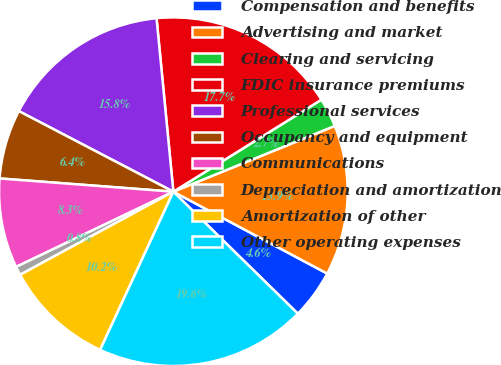<chart> <loc_0><loc_0><loc_500><loc_500><pie_chart><fcel>Compensation and benefits<fcel>Advertising and market<fcel>Clearing and servicing<fcel>FDIC insurance premiums<fcel>Professional services<fcel>Occupancy and equipment<fcel>Communications<fcel>Depreciation and amortization<fcel>Amortization of other<fcel>Other operating expenses<nl><fcel>4.56%<fcel>13.94%<fcel>2.69%<fcel>17.69%<fcel>15.81%<fcel>6.44%<fcel>8.31%<fcel>0.81%<fcel>10.19%<fcel>19.56%<nl></chart> 